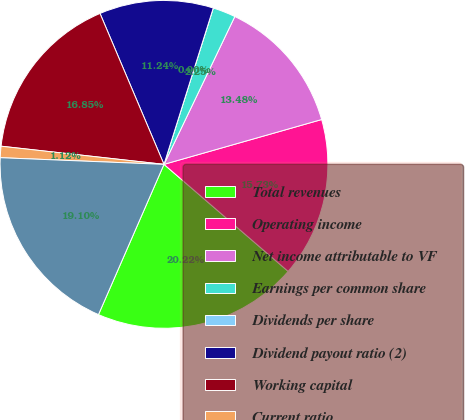Convert chart to OTSL. <chart><loc_0><loc_0><loc_500><loc_500><pie_chart><fcel>Total revenues<fcel>Operating income<fcel>Net income attributable to VF<fcel>Earnings per common share<fcel>Dividends per share<fcel>Dividend payout ratio (2)<fcel>Working capital<fcel>Current ratio<fcel>Total assets<nl><fcel>20.22%<fcel>15.73%<fcel>13.48%<fcel>2.25%<fcel>0.0%<fcel>11.24%<fcel>16.85%<fcel>1.12%<fcel>19.1%<nl></chart> 